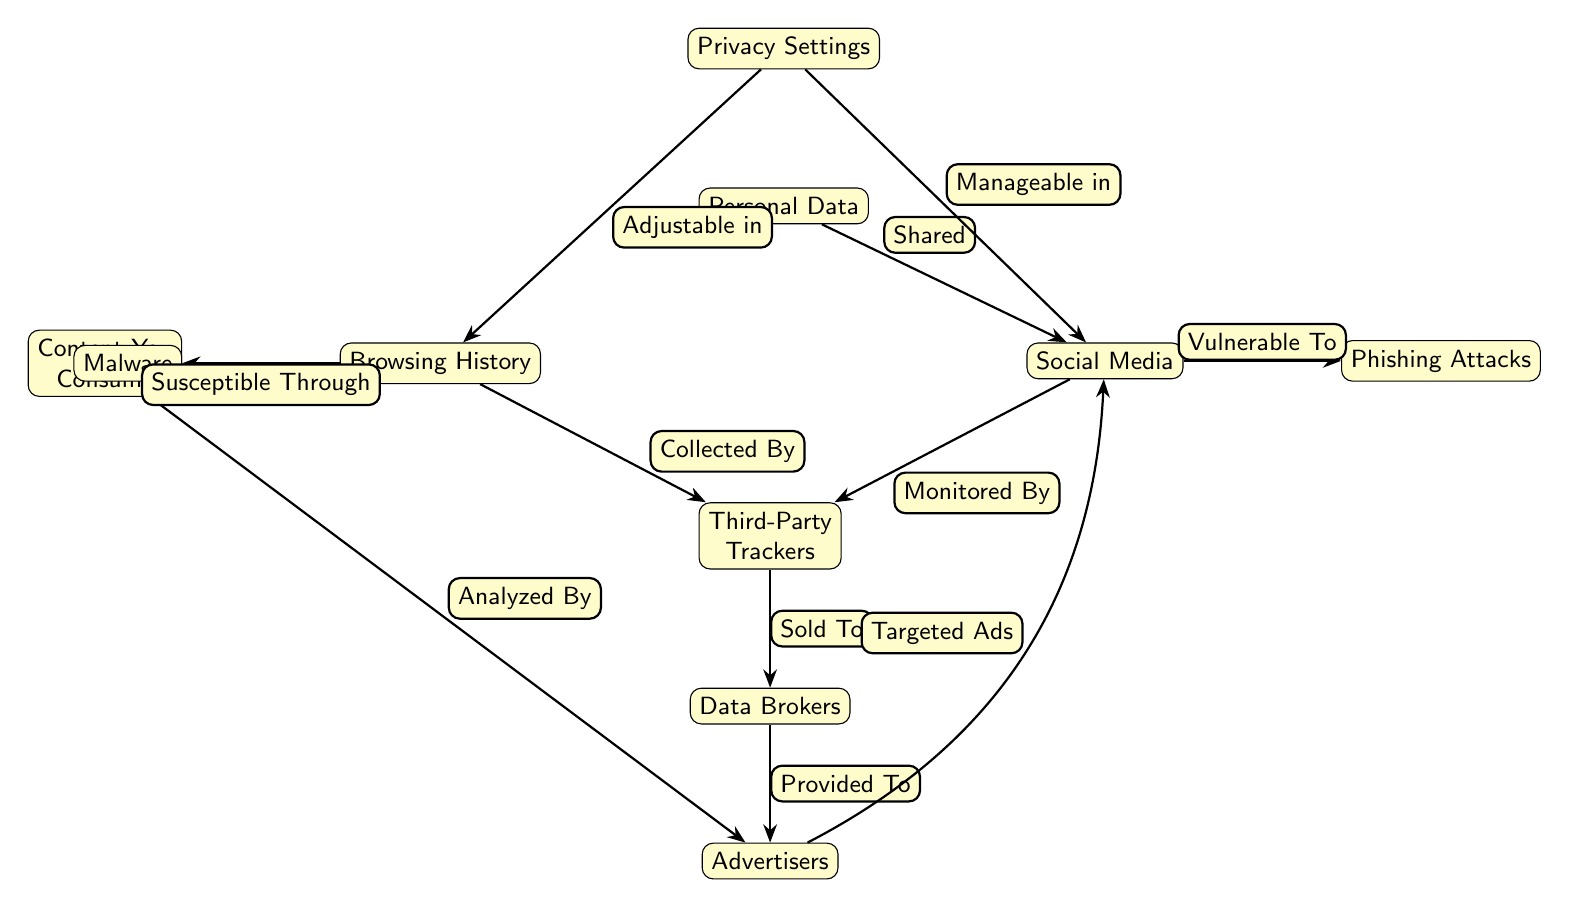What is the top node in the diagram? The top node is labeled "Personal Data." It is the starting point of the flow of information that connects to other nodes in the diagram.
Answer: Personal Data What are the nodes that relate to advertising? The nodes that relate to advertising are "Advertisers" and "Third-Party Trackers." "Advertisers" receive data from "Data Brokers," which in turn receive data from "Third-Party Trackers."
Answer: Advertisers, Third-Party Trackers How many total nodes are present in the diagram? To find the total number of nodes, we count each distinct node represented: Personal Data, Social Media, Browsing History, Third-Party Trackers, Data Brokers, User Consumed Content, Advertisers, Phishing Attacks, Malware, and Privacy Settings, which totals to ten.
Answer: 10 What relationship does "Privacy Settings" have with "Social Media"? "Privacy Settings" has the relationship labeled "Manageable in" with "Social Media," indicating that users can manage their privacy settings related to social media platforms.
Answer: Manageable in Which node is "Content You Consume" analyzed by? The node "Content You Consume" is analyzed by "Advertisers," as represented by the edge labeled "Analyzed By." This indicates that advertisers look at the content that users consume to gather insights for targeted marketing.
Answer: Advertisers Which two nodes indicate vulnerability to security threats? The nodes indicating vulnerability are "Phishing Attacks" and "Malware." "Phishing Attacks" is linked to "Social Media," while "Malware" connects to "Browsing History." Both highlight potential threats that can compromise user security.
Answer: Phishing Attacks, Malware What is the direction of the relationship between "Third-Party Trackers" and "Data Brokers"? The direction of the relationship is from "Third-Party Trackers" to "Data Brokers," as the edge is labeled "Sold To," indicating that data collected by third-party trackers is sold to data brokers.
Answer: Sold To Which node is managed through privacy settings related to browsing? The node managed through privacy settings related to browsing is "Browsing History," as indicated by the edge labeled "Adjustable in," which shows that users can control settings in relation to their browsing history.
Answer: Browsing History How is "Social Media" related to "Advertisers"? "Social Media" is related to "Advertisers" through the edge labeled "Targeted Ads," indicating that advertisers use data from social media to create targeted advertisement campaigns aimed at users on those platforms.
Answer: Targeted Ads 